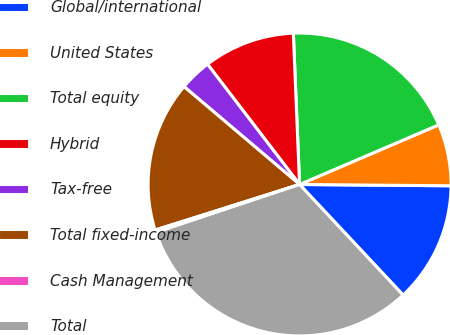<chart> <loc_0><loc_0><loc_500><loc_500><pie_chart><fcel>Global/international<fcel>United States<fcel>Total equity<fcel>Hybrid<fcel>Tax-free<fcel>Total fixed-income<fcel>Cash Management<fcel>Total<nl><fcel>12.89%<fcel>6.58%<fcel>19.21%<fcel>9.74%<fcel>3.42%<fcel>16.05%<fcel>0.26%<fcel>31.85%<nl></chart> 